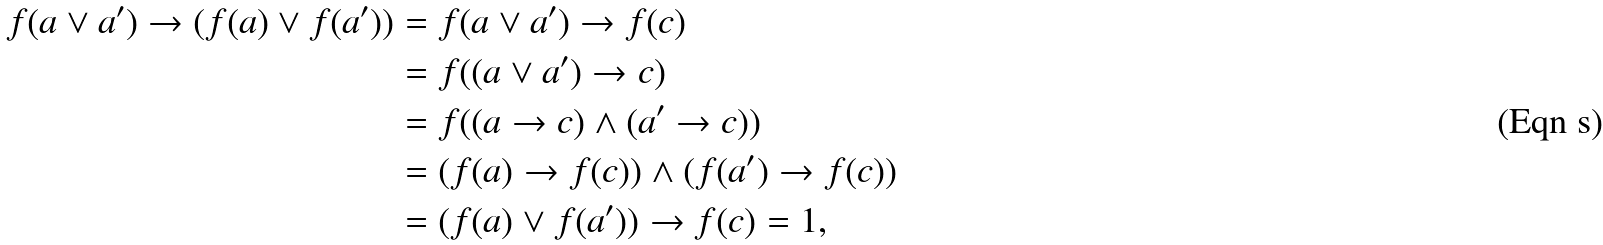<formula> <loc_0><loc_0><loc_500><loc_500>f ( a \vee a ^ { \prime } ) \to ( f ( a ) \vee f ( a ^ { \prime } ) ) & = f ( a \vee a ^ { \prime } ) \to f ( c ) \\ & = f ( ( a \vee a ^ { \prime } ) \to c ) \\ & = f ( ( a \to c ) \wedge ( a ^ { \prime } \to c ) ) \\ & = ( f ( a ) \to f ( c ) ) \wedge ( f ( a ^ { \prime } ) \to f ( c ) ) \\ & = ( f ( a ) \vee f ( a ^ { \prime } ) ) \to f ( c ) = 1 ,</formula> 